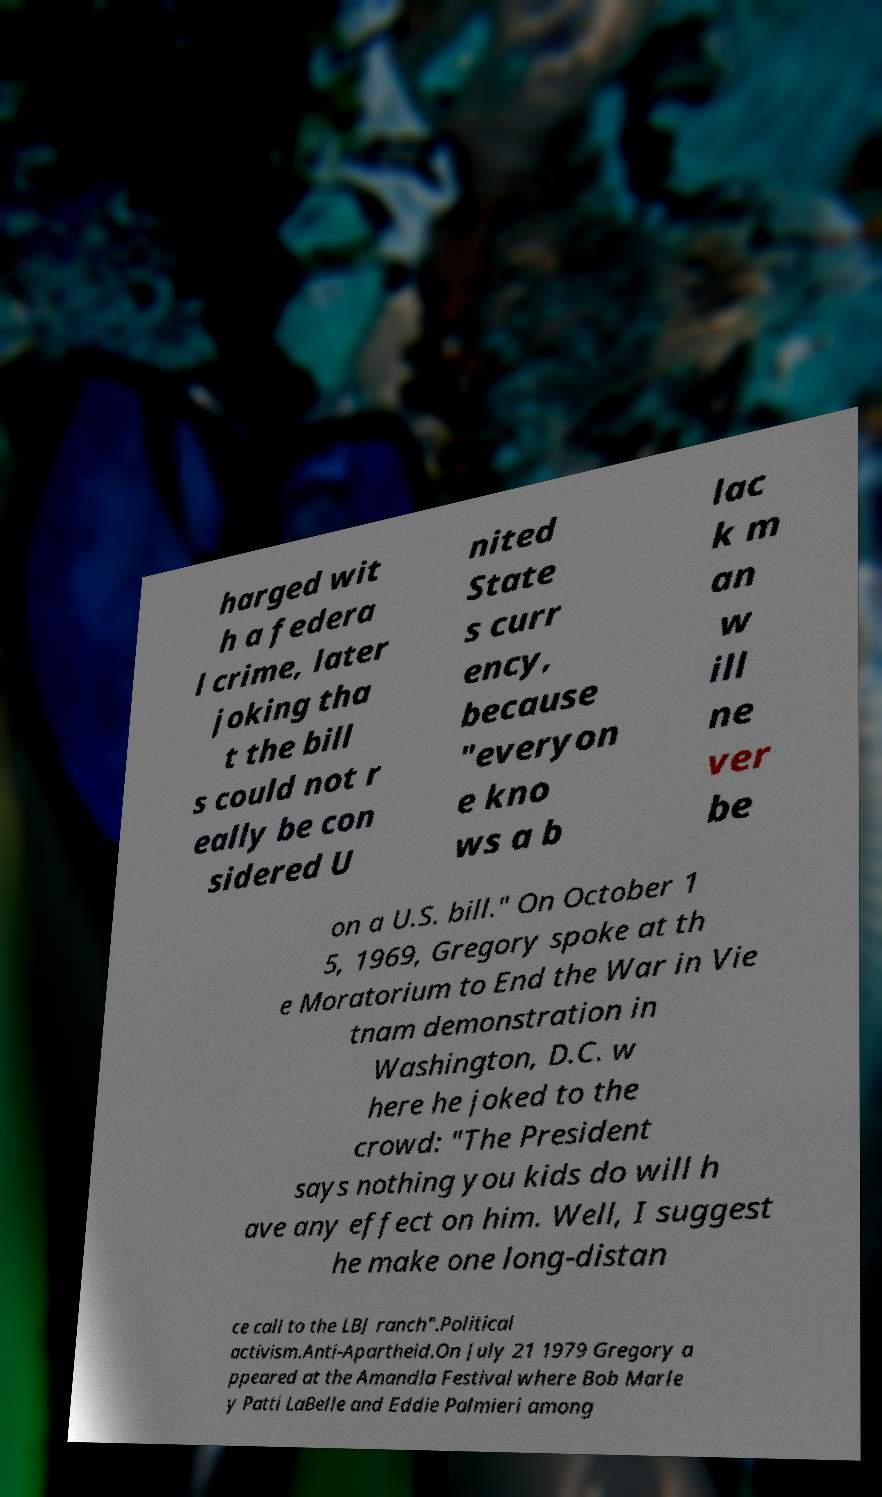Please identify and transcribe the text found in this image. harged wit h a federa l crime, later joking tha t the bill s could not r eally be con sidered U nited State s curr ency, because "everyon e kno ws a b lac k m an w ill ne ver be on a U.S. bill." On October 1 5, 1969, Gregory spoke at th e Moratorium to End the War in Vie tnam demonstration in Washington, D.C. w here he joked to the crowd: "The President says nothing you kids do will h ave any effect on him. Well, I suggest he make one long-distan ce call to the LBJ ranch".Political activism.Anti-Apartheid.On July 21 1979 Gregory a ppeared at the Amandla Festival where Bob Marle y Patti LaBelle and Eddie Palmieri among 